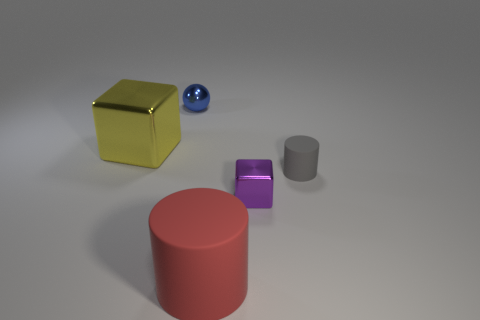Is there anything else that has the same shape as the blue metallic object? Regarding the shape of the blue metallic object, which appears to be a sphere, there are no other items in the image that share the exact same three-dimensional form. 